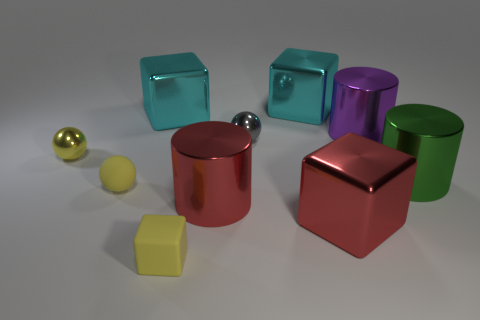Is there a red metal cylinder of the same size as the rubber ball? No, there is not a red metal cylinder of the same size as the rubber ball in the image. We can see a red cylinder, but it is larger than both the yellow rubber ball and the smaller silver ball. 